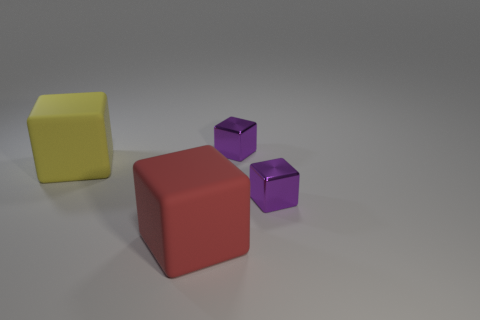What number of cylinders are either large yellow things or rubber things?
Keep it short and to the point. 0. Are there any big red rubber objects?
Ensure brevity in your answer.  Yes. What is the shape of the small purple shiny object that is behind the rubber cube behind the red block?
Offer a very short reply. Cube. How many purple things are either tiny cubes or rubber things?
Keep it short and to the point. 2. Is the size of the yellow cube the same as the red block?
Make the answer very short. Yes. Are the big yellow cube and the purple thing that is in front of the yellow object made of the same material?
Your answer should be compact. No. How many blocks are in front of the big yellow rubber block and to the right of the big red rubber block?
Offer a very short reply. 1. How many other things are there of the same material as the large red cube?
Keep it short and to the point. 1. Are the big yellow thing that is left of the big red thing and the large red cube made of the same material?
Keep it short and to the point. Yes. What is the size of the metallic block right of the purple thing that is to the left of the small metallic cube in front of the yellow block?
Make the answer very short. Small. 